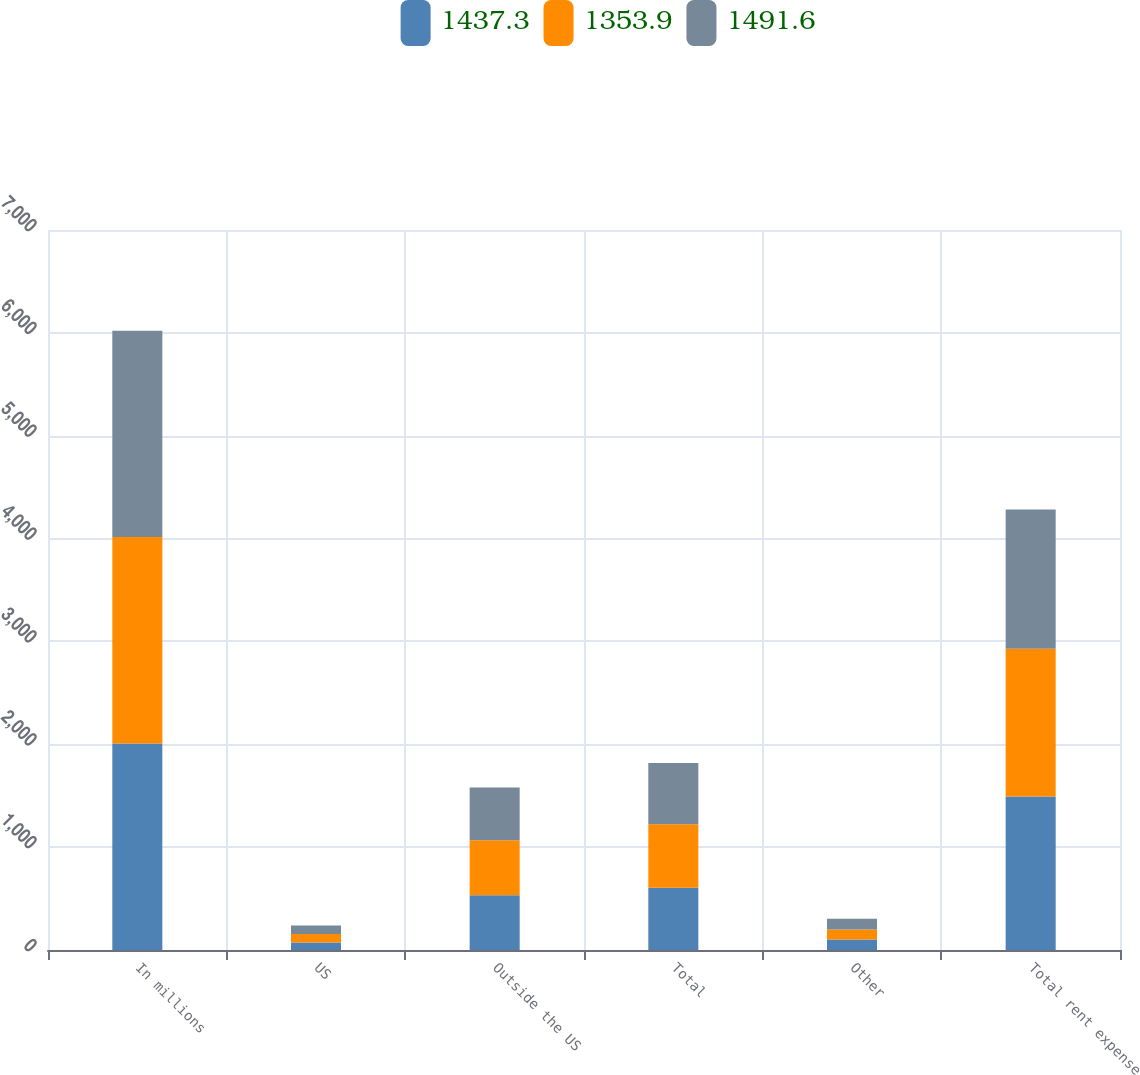Convert chart. <chart><loc_0><loc_0><loc_500><loc_500><stacked_bar_chart><ecel><fcel>In millions<fcel>US<fcel>Outside the US<fcel>Total<fcel>Other<fcel>Total rent expense<nl><fcel>1437.3<fcel>2008<fcel>73.7<fcel>532<fcel>605.7<fcel>101.8<fcel>1491.6<nl><fcel>1353.9<fcel>2007<fcel>82<fcel>533.9<fcel>615.9<fcel>98.5<fcel>1437.3<nl><fcel>1491.6<fcel>2006<fcel>81.6<fcel>515.1<fcel>596.7<fcel>104.5<fcel>1353.9<nl></chart> 